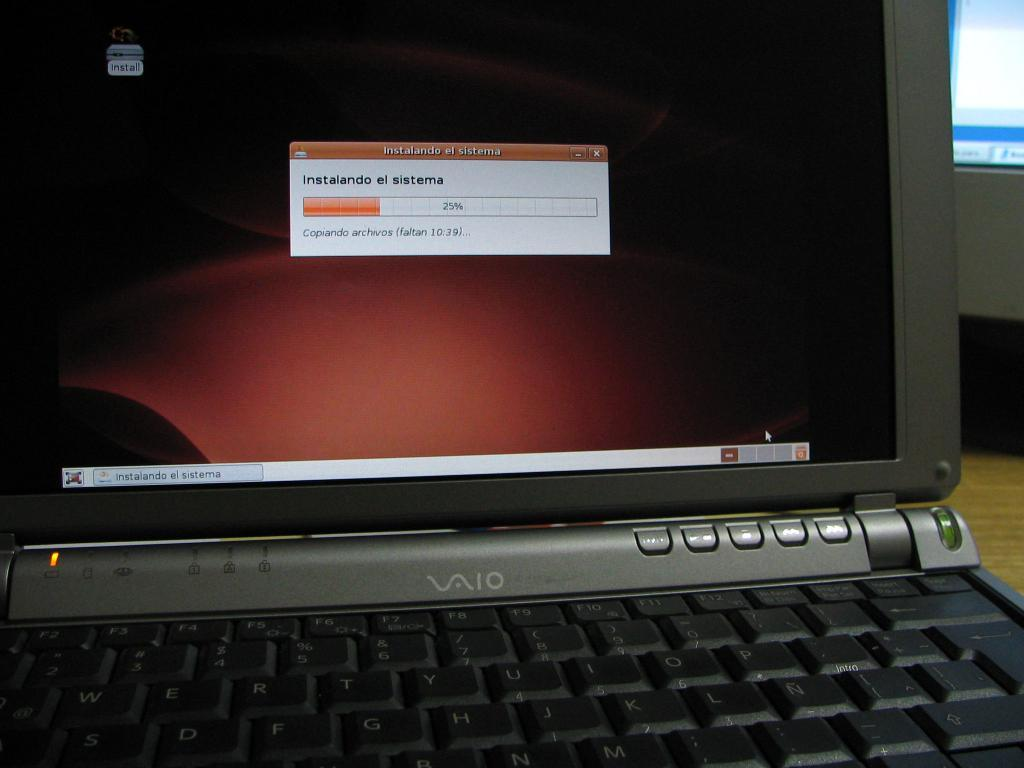<image>
Create a compact narrative representing the image presented. a Vaio laptop is sitting open, and turned on 